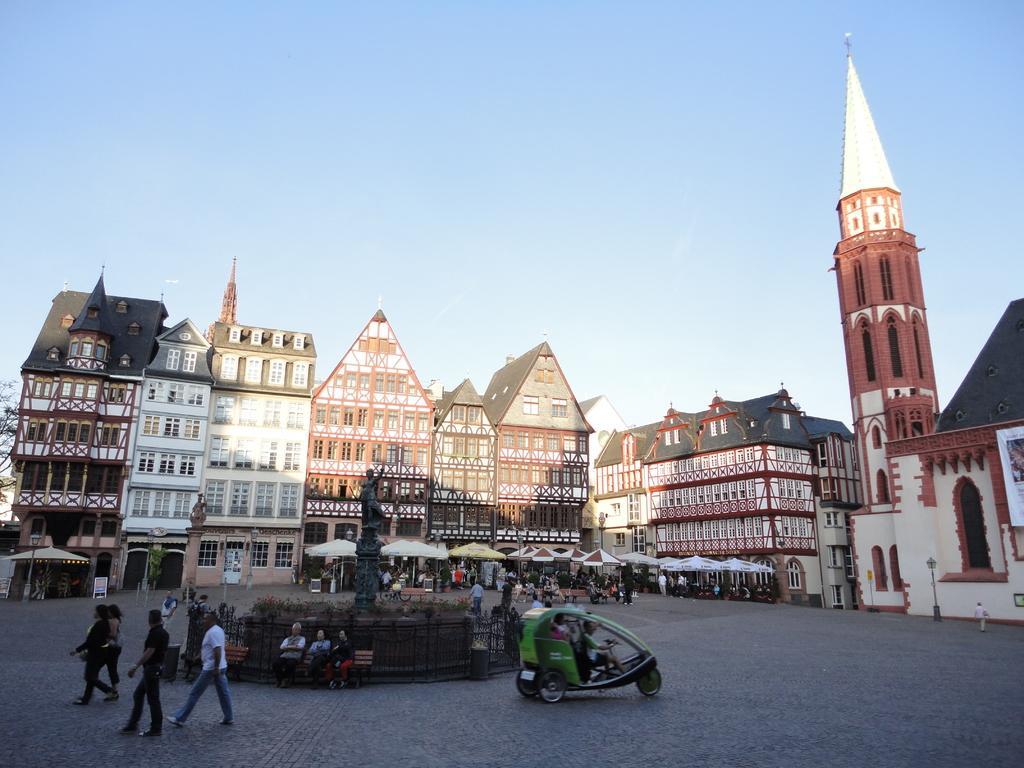In one or two sentences, can you explain what this image depicts? In this picture there are buildings with roof tiles and windows. Before them, there are umbrellas. Under it there are people. At the bottom left, there is a statue in the center. Before the statue, there are people sitting on the bench. Beside it there is a vehicle and a person riding it. Towards the bottom left, there are people walking. On the top, there is a sky. 